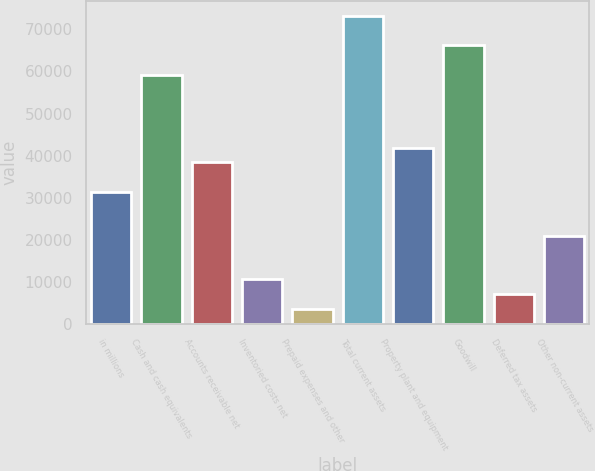Convert chart. <chart><loc_0><loc_0><loc_500><loc_500><bar_chart><fcel>in millions<fcel>Cash and cash equivalents<fcel>Accounts receivable net<fcel>Inventoried costs net<fcel>Prepaid expenses and other<fcel>Total current assets<fcel>Property plant and equipment<fcel>Goodwill<fcel>Deferred tax assets<fcel>Other non-current assets<nl><fcel>31442.7<fcel>59237.1<fcel>38391.3<fcel>10596.9<fcel>3648.3<fcel>73134.3<fcel>41865.6<fcel>66185.7<fcel>7122.6<fcel>21019.8<nl></chart> 